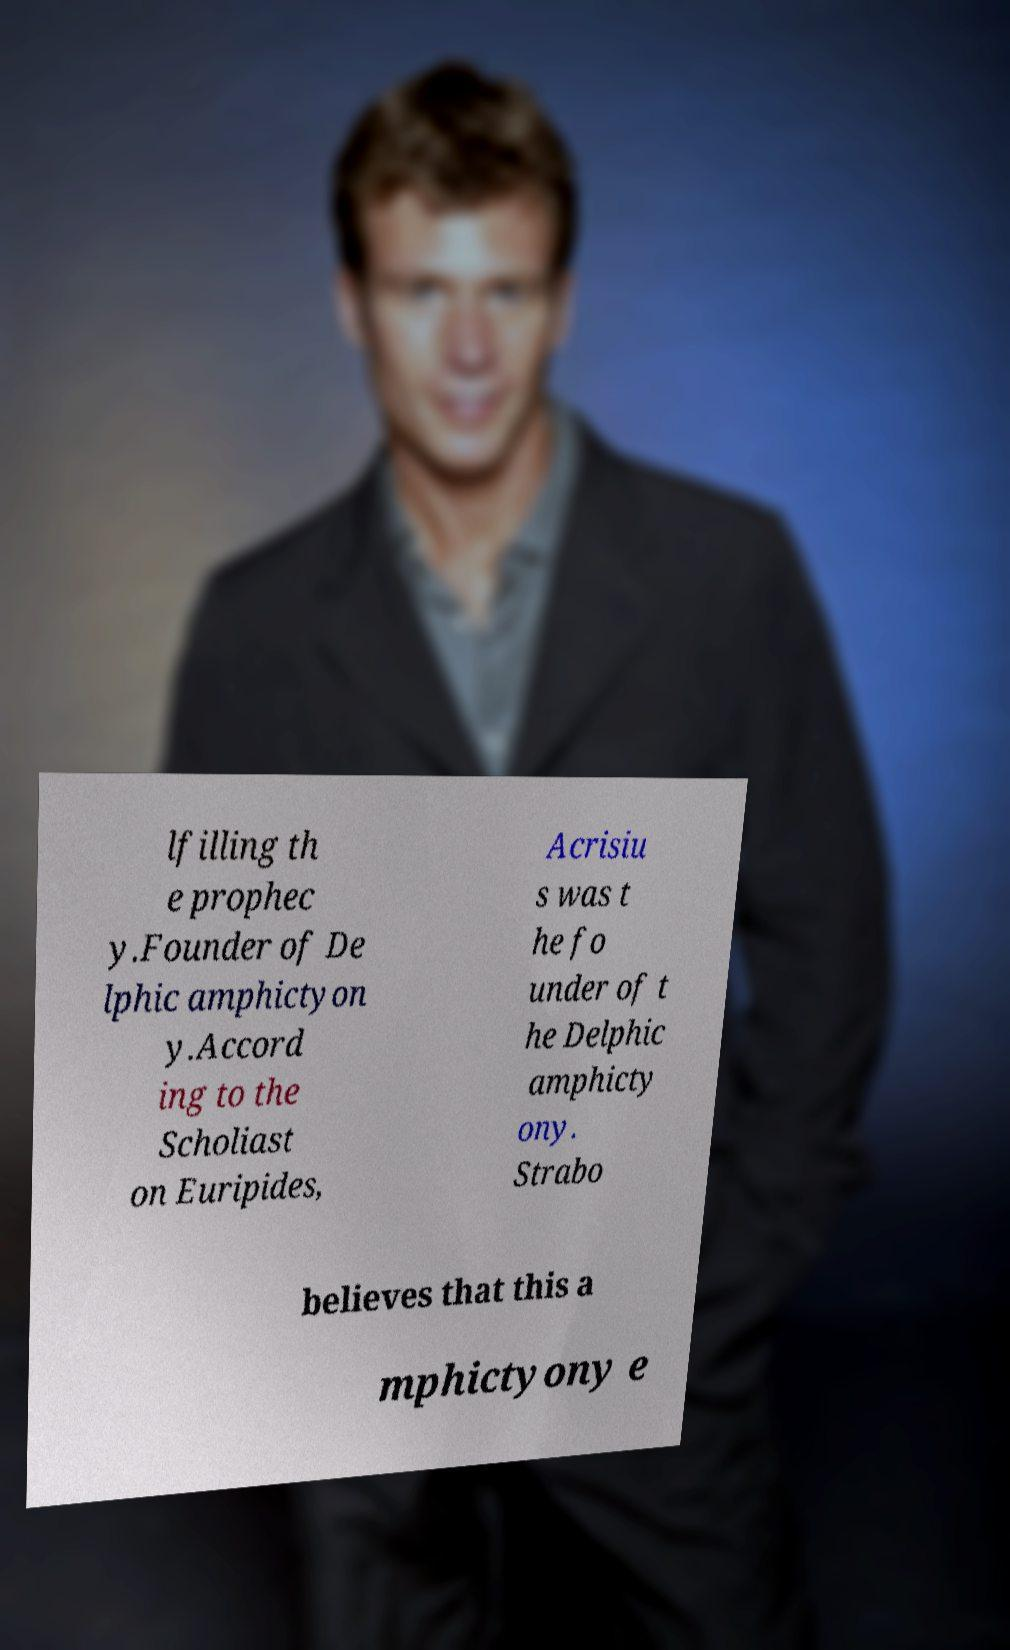Can you accurately transcribe the text from the provided image for me? lfilling th e prophec y.Founder of De lphic amphictyon y.Accord ing to the Scholiast on Euripides, Acrisiu s was t he fo under of t he Delphic amphicty ony. Strabo believes that this a mphictyony e 